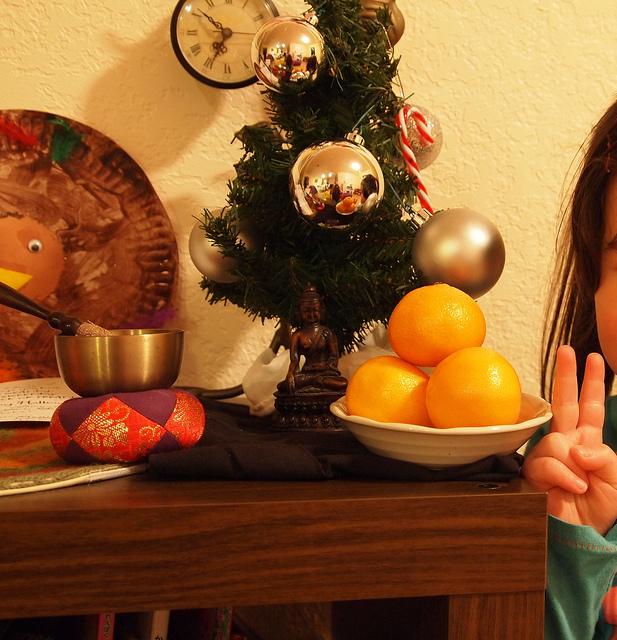How many different colors are in this picture?
Answer briefly. Many. What time does the clock say?
Keep it brief. 7:50. What is the color of the fruit in the bowl?
Give a very brief answer. Orange. 